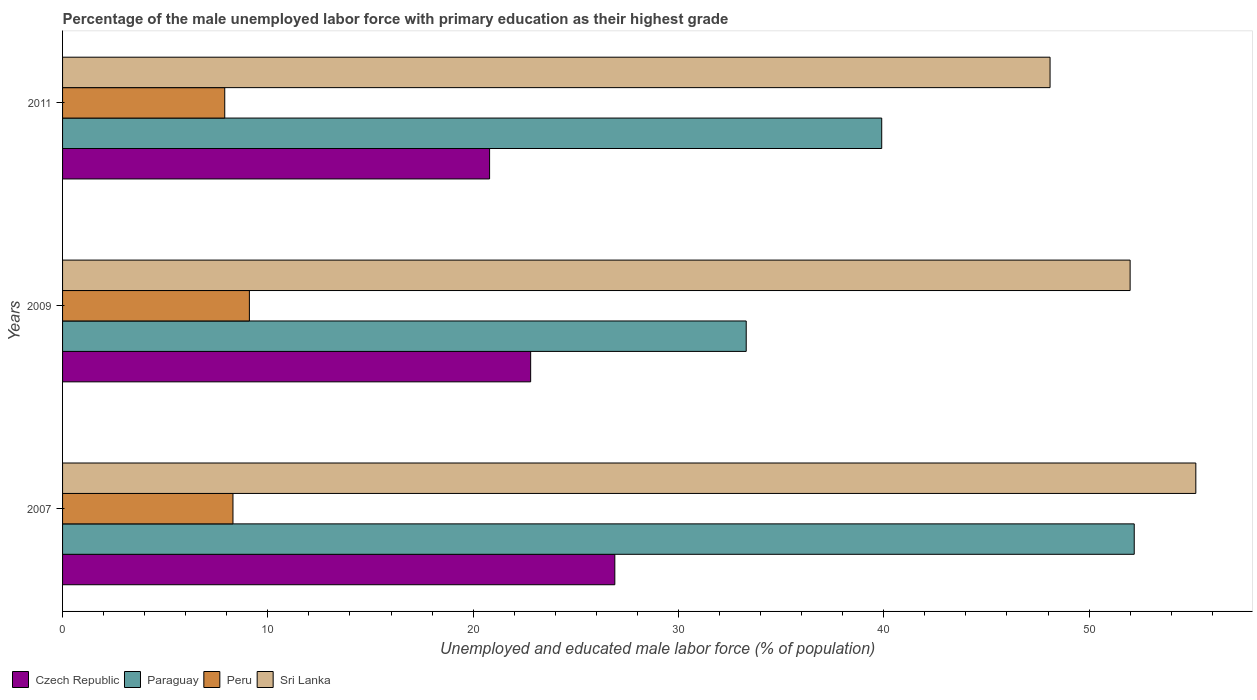How many different coloured bars are there?
Keep it short and to the point. 4. How many groups of bars are there?
Your answer should be compact. 3. Are the number of bars per tick equal to the number of legend labels?
Make the answer very short. Yes. Are the number of bars on each tick of the Y-axis equal?
Your response must be concise. Yes. What is the label of the 2nd group of bars from the top?
Ensure brevity in your answer.  2009. What is the percentage of the unemployed male labor force with primary education in Paraguay in 2011?
Your answer should be compact. 39.9. Across all years, what is the maximum percentage of the unemployed male labor force with primary education in Czech Republic?
Ensure brevity in your answer.  26.9. Across all years, what is the minimum percentage of the unemployed male labor force with primary education in Sri Lanka?
Provide a succinct answer. 48.1. What is the total percentage of the unemployed male labor force with primary education in Paraguay in the graph?
Provide a short and direct response. 125.4. What is the difference between the percentage of the unemployed male labor force with primary education in Paraguay in 2007 and that in 2011?
Offer a terse response. 12.3. What is the difference between the percentage of the unemployed male labor force with primary education in Sri Lanka in 2009 and the percentage of the unemployed male labor force with primary education in Czech Republic in 2007?
Provide a short and direct response. 25.1. What is the average percentage of the unemployed male labor force with primary education in Paraguay per year?
Make the answer very short. 41.8. In the year 2007, what is the difference between the percentage of the unemployed male labor force with primary education in Paraguay and percentage of the unemployed male labor force with primary education in Sri Lanka?
Your answer should be very brief. -3. In how many years, is the percentage of the unemployed male labor force with primary education in Paraguay greater than 16 %?
Provide a short and direct response. 3. What is the ratio of the percentage of the unemployed male labor force with primary education in Czech Republic in 2007 to that in 2009?
Your response must be concise. 1.18. Is the percentage of the unemployed male labor force with primary education in Sri Lanka in 2007 less than that in 2011?
Keep it short and to the point. No. What is the difference between the highest and the second highest percentage of the unemployed male labor force with primary education in Peru?
Keep it short and to the point. 0.8. What is the difference between the highest and the lowest percentage of the unemployed male labor force with primary education in Czech Republic?
Provide a succinct answer. 6.1. In how many years, is the percentage of the unemployed male labor force with primary education in Sri Lanka greater than the average percentage of the unemployed male labor force with primary education in Sri Lanka taken over all years?
Provide a succinct answer. 2. What does the 2nd bar from the top in 2011 represents?
Your answer should be very brief. Peru. What does the 2nd bar from the bottom in 2011 represents?
Your answer should be compact. Paraguay. Is it the case that in every year, the sum of the percentage of the unemployed male labor force with primary education in Paraguay and percentage of the unemployed male labor force with primary education in Peru is greater than the percentage of the unemployed male labor force with primary education in Czech Republic?
Make the answer very short. Yes. How many bars are there?
Offer a terse response. 12. Are all the bars in the graph horizontal?
Provide a short and direct response. Yes. How many years are there in the graph?
Ensure brevity in your answer.  3. What is the difference between two consecutive major ticks on the X-axis?
Give a very brief answer. 10. Are the values on the major ticks of X-axis written in scientific E-notation?
Give a very brief answer. No. Does the graph contain any zero values?
Make the answer very short. No. Does the graph contain grids?
Keep it short and to the point. No. What is the title of the graph?
Offer a very short reply. Percentage of the male unemployed labor force with primary education as their highest grade. Does "Europe(developing only)" appear as one of the legend labels in the graph?
Your answer should be compact. No. What is the label or title of the X-axis?
Ensure brevity in your answer.  Unemployed and educated male labor force (% of population). What is the Unemployed and educated male labor force (% of population) in Czech Republic in 2007?
Provide a short and direct response. 26.9. What is the Unemployed and educated male labor force (% of population) in Paraguay in 2007?
Make the answer very short. 52.2. What is the Unemployed and educated male labor force (% of population) in Peru in 2007?
Provide a succinct answer. 8.3. What is the Unemployed and educated male labor force (% of population) in Sri Lanka in 2007?
Make the answer very short. 55.2. What is the Unemployed and educated male labor force (% of population) in Czech Republic in 2009?
Give a very brief answer. 22.8. What is the Unemployed and educated male labor force (% of population) in Paraguay in 2009?
Ensure brevity in your answer.  33.3. What is the Unemployed and educated male labor force (% of population) in Peru in 2009?
Your answer should be compact. 9.1. What is the Unemployed and educated male labor force (% of population) in Czech Republic in 2011?
Offer a very short reply. 20.8. What is the Unemployed and educated male labor force (% of population) in Paraguay in 2011?
Ensure brevity in your answer.  39.9. What is the Unemployed and educated male labor force (% of population) in Peru in 2011?
Keep it short and to the point. 7.9. What is the Unemployed and educated male labor force (% of population) of Sri Lanka in 2011?
Make the answer very short. 48.1. Across all years, what is the maximum Unemployed and educated male labor force (% of population) of Czech Republic?
Provide a succinct answer. 26.9. Across all years, what is the maximum Unemployed and educated male labor force (% of population) in Paraguay?
Keep it short and to the point. 52.2. Across all years, what is the maximum Unemployed and educated male labor force (% of population) of Peru?
Provide a short and direct response. 9.1. Across all years, what is the maximum Unemployed and educated male labor force (% of population) of Sri Lanka?
Provide a short and direct response. 55.2. Across all years, what is the minimum Unemployed and educated male labor force (% of population) of Czech Republic?
Provide a succinct answer. 20.8. Across all years, what is the minimum Unemployed and educated male labor force (% of population) in Paraguay?
Offer a very short reply. 33.3. Across all years, what is the minimum Unemployed and educated male labor force (% of population) of Peru?
Offer a terse response. 7.9. Across all years, what is the minimum Unemployed and educated male labor force (% of population) in Sri Lanka?
Provide a short and direct response. 48.1. What is the total Unemployed and educated male labor force (% of population) in Czech Republic in the graph?
Give a very brief answer. 70.5. What is the total Unemployed and educated male labor force (% of population) of Paraguay in the graph?
Your response must be concise. 125.4. What is the total Unemployed and educated male labor force (% of population) in Peru in the graph?
Provide a succinct answer. 25.3. What is the total Unemployed and educated male labor force (% of population) in Sri Lanka in the graph?
Offer a very short reply. 155.3. What is the difference between the Unemployed and educated male labor force (% of population) in Czech Republic in 2007 and that in 2009?
Make the answer very short. 4.1. What is the difference between the Unemployed and educated male labor force (% of population) in Paraguay in 2007 and that in 2009?
Your response must be concise. 18.9. What is the difference between the Unemployed and educated male labor force (% of population) of Paraguay in 2007 and that in 2011?
Your answer should be compact. 12.3. What is the difference between the Unemployed and educated male labor force (% of population) in Peru in 2007 and that in 2011?
Provide a short and direct response. 0.4. What is the difference between the Unemployed and educated male labor force (% of population) in Paraguay in 2009 and that in 2011?
Provide a short and direct response. -6.6. What is the difference between the Unemployed and educated male labor force (% of population) in Czech Republic in 2007 and the Unemployed and educated male labor force (% of population) in Peru in 2009?
Give a very brief answer. 17.8. What is the difference between the Unemployed and educated male labor force (% of population) in Czech Republic in 2007 and the Unemployed and educated male labor force (% of population) in Sri Lanka in 2009?
Offer a very short reply. -25.1. What is the difference between the Unemployed and educated male labor force (% of population) in Paraguay in 2007 and the Unemployed and educated male labor force (% of population) in Peru in 2009?
Offer a terse response. 43.1. What is the difference between the Unemployed and educated male labor force (% of population) of Paraguay in 2007 and the Unemployed and educated male labor force (% of population) of Sri Lanka in 2009?
Provide a succinct answer. 0.2. What is the difference between the Unemployed and educated male labor force (% of population) in Peru in 2007 and the Unemployed and educated male labor force (% of population) in Sri Lanka in 2009?
Ensure brevity in your answer.  -43.7. What is the difference between the Unemployed and educated male labor force (% of population) in Czech Republic in 2007 and the Unemployed and educated male labor force (% of population) in Sri Lanka in 2011?
Keep it short and to the point. -21.2. What is the difference between the Unemployed and educated male labor force (% of population) of Paraguay in 2007 and the Unemployed and educated male labor force (% of population) of Peru in 2011?
Your answer should be compact. 44.3. What is the difference between the Unemployed and educated male labor force (% of population) in Peru in 2007 and the Unemployed and educated male labor force (% of population) in Sri Lanka in 2011?
Ensure brevity in your answer.  -39.8. What is the difference between the Unemployed and educated male labor force (% of population) of Czech Republic in 2009 and the Unemployed and educated male labor force (% of population) of Paraguay in 2011?
Make the answer very short. -17.1. What is the difference between the Unemployed and educated male labor force (% of population) of Czech Republic in 2009 and the Unemployed and educated male labor force (% of population) of Peru in 2011?
Offer a very short reply. 14.9. What is the difference between the Unemployed and educated male labor force (% of population) of Czech Republic in 2009 and the Unemployed and educated male labor force (% of population) of Sri Lanka in 2011?
Offer a very short reply. -25.3. What is the difference between the Unemployed and educated male labor force (% of population) in Paraguay in 2009 and the Unemployed and educated male labor force (% of population) in Peru in 2011?
Provide a succinct answer. 25.4. What is the difference between the Unemployed and educated male labor force (% of population) of Paraguay in 2009 and the Unemployed and educated male labor force (% of population) of Sri Lanka in 2011?
Make the answer very short. -14.8. What is the difference between the Unemployed and educated male labor force (% of population) of Peru in 2009 and the Unemployed and educated male labor force (% of population) of Sri Lanka in 2011?
Ensure brevity in your answer.  -39. What is the average Unemployed and educated male labor force (% of population) of Paraguay per year?
Ensure brevity in your answer.  41.8. What is the average Unemployed and educated male labor force (% of population) in Peru per year?
Offer a terse response. 8.43. What is the average Unemployed and educated male labor force (% of population) of Sri Lanka per year?
Your answer should be very brief. 51.77. In the year 2007, what is the difference between the Unemployed and educated male labor force (% of population) in Czech Republic and Unemployed and educated male labor force (% of population) in Paraguay?
Make the answer very short. -25.3. In the year 2007, what is the difference between the Unemployed and educated male labor force (% of population) in Czech Republic and Unemployed and educated male labor force (% of population) in Peru?
Keep it short and to the point. 18.6. In the year 2007, what is the difference between the Unemployed and educated male labor force (% of population) of Czech Republic and Unemployed and educated male labor force (% of population) of Sri Lanka?
Your response must be concise. -28.3. In the year 2007, what is the difference between the Unemployed and educated male labor force (% of population) of Paraguay and Unemployed and educated male labor force (% of population) of Peru?
Make the answer very short. 43.9. In the year 2007, what is the difference between the Unemployed and educated male labor force (% of population) of Paraguay and Unemployed and educated male labor force (% of population) of Sri Lanka?
Provide a succinct answer. -3. In the year 2007, what is the difference between the Unemployed and educated male labor force (% of population) of Peru and Unemployed and educated male labor force (% of population) of Sri Lanka?
Keep it short and to the point. -46.9. In the year 2009, what is the difference between the Unemployed and educated male labor force (% of population) in Czech Republic and Unemployed and educated male labor force (% of population) in Sri Lanka?
Ensure brevity in your answer.  -29.2. In the year 2009, what is the difference between the Unemployed and educated male labor force (% of population) of Paraguay and Unemployed and educated male labor force (% of population) of Peru?
Give a very brief answer. 24.2. In the year 2009, what is the difference between the Unemployed and educated male labor force (% of population) of Paraguay and Unemployed and educated male labor force (% of population) of Sri Lanka?
Make the answer very short. -18.7. In the year 2009, what is the difference between the Unemployed and educated male labor force (% of population) of Peru and Unemployed and educated male labor force (% of population) of Sri Lanka?
Ensure brevity in your answer.  -42.9. In the year 2011, what is the difference between the Unemployed and educated male labor force (% of population) in Czech Republic and Unemployed and educated male labor force (% of population) in Paraguay?
Your answer should be very brief. -19.1. In the year 2011, what is the difference between the Unemployed and educated male labor force (% of population) in Czech Republic and Unemployed and educated male labor force (% of population) in Sri Lanka?
Your answer should be very brief. -27.3. In the year 2011, what is the difference between the Unemployed and educated male labor force (% of population) of Paraguay and Unemployed and educated male labor force (% of population) of Peru?
Provide a succinct answer. 32. In the year 2011, what is the difference between the Unemployed and educated male labor force (% of population) in Peru and Unemployed and educated male labor force (% of population) in Sri Lanka?
Your answer should be compact. -40.2. What is the ratio of the Unemployed and educated male labor force (% of population) of Czech Republic in 2007 to that in 2009?
Make the answer very short. 1.18. What is the ratio of the Unemployed and educated male labor force (% of population) of Paraguay in 2007 to that in 2009?
Provide a short and direct response. 1.57. What is the ratio of the Unemployed and educated male labor force (% of population) in Peru in 2007 to that in 2009?
Provide a succinct answer. 0.91. What is the ratio of the Unemployed and educated male labor force (% of population) of Sri Lanka in 2007 to that in 2009?
Keep it short and to the point. 1.06. What is the ratio of the Unemployed and educated male labor force (% of population) in Czech Republic in 2007 to that in 2011?
Your answer should be compact. 1.29. What is the ratio of the Unemployed and educated male labor force (% of population) in Paraguay in 2007 to that in 2011?
Ensure brevity in your answer.  1.31. What is the ratio of the Unemployed and educated male labor force (% of population) in Peru in 2007 to that in 2011?
Your answer should be compact. 1.05. What is the ratio of the Unemployed and educated male labor force (% of population) of Sri Lanka in 2007 to that in 2011?
Make the answer very short. 1.15. What is the ratio of the Unemployed and educated male labor force (% of population) in Czech Republic in 2009 to that in 2011?
Give a very brief answer. 1.1. What is the ratio of the Unemployed and educated male labor force (% of population) in Paraguay in 2009 to that in 2011?
Ensure brevity in your answer.  0.83. What is the ratio of the Unemployed and educated male labor force (% of population) of Peru in 2009 to that in 2011?
Offer a very short reply. 1.15. What is the ratio of the Unemployed and educated male labor force (% of population) of Sri Lanka in 2009 to that in 2011?
Ensure brevity in your answer.  1.08. What is the difference between the highest and the second highest Unemployed and educated male labor force (% of population) in Czech Republic?
Provide a succinct answer. 4.1. What is the difference between the highest and the second highest Unemployed and educated male labor force (% of population) in Sri Lanka?
Provide a succinct answer. 3.2. 